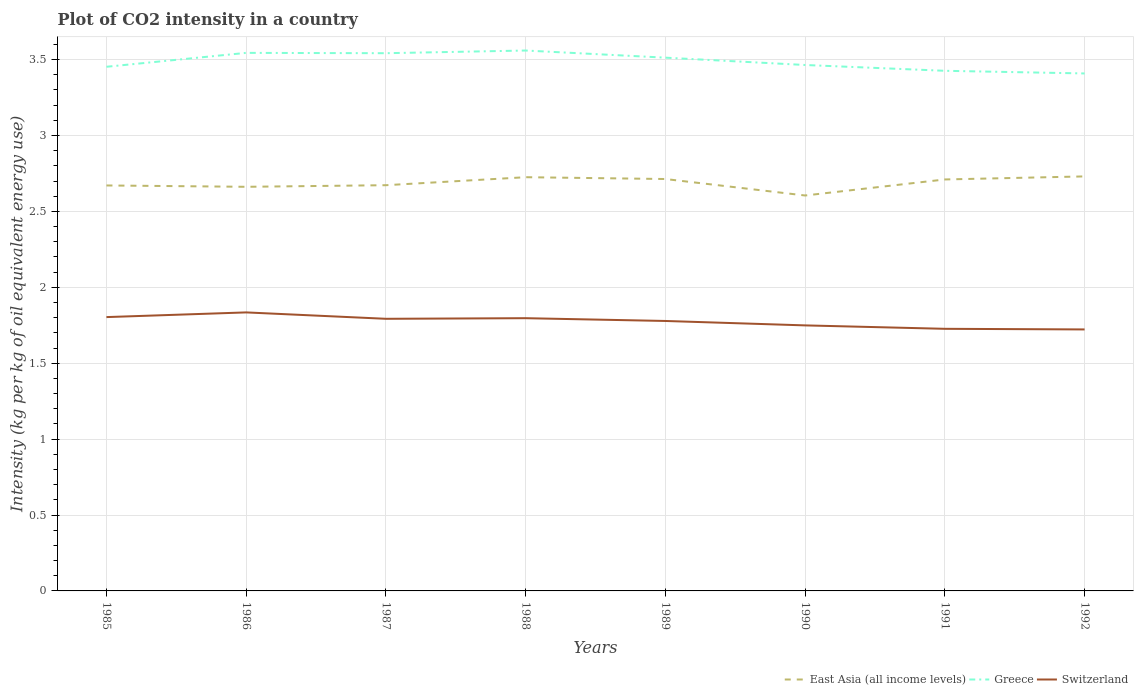Does the line corresponding to Switzerland intersect with the line corresponding to East Asia (all income levels)?
Give a very brief answer. No. Across all years, what is the maximum CO2 intensity in in Greece?
Your response must be concise. 3.41. In which year was the CO2 intensity in in East Asia (all income levels) maximum?
Your answer should be very brief. 1990. What is the total CO2 intensity in in Greece in the graph?
Offer a very short reply. 0.06. What is the difference between the highest and the second highest CO2 intensity in in Switzerland?
Offer a terse response. 0.11. Is the CO2 intensity in in Switzerland strictly greater than the CO2 intensity in in Greece over the years?
Provide a succinct answer. Yes. How many years are there in the graph?
Make the answer very short. 8. Are the values on the major ticks of Y-axis written in scientific E-notation?
Provide a short and direct response. No. Where does the legend appear in the graph?
Your answer should be compact. Bottom right. How are the legend labels stacked?
Your answer should be compact. Horizontal. What is the title of the graph?
Ensure brevity in your answer.  Plot of CO2 intensity in a country. What is the label or title of the Y-axis?
Provide a short and direct response. Intensity (kg per kg of oil equivalent energy use). What is the Intensity (kg per kg of oil equivalent energy use) in East Asia (all income levels) in 1985?
Provide a succinct answer. 2.67. What is the Intensity (kg per kg of oil equivalent energy use) in Greece in 1985?
Keep it short and to the point. 3.45. What is the Intensity (kg per kg of oil equivalent energy use) in Switzerland in 1985?
Provide a short and direct response. 1.8. What is the Intensity (kg per kg of oil equivalent energy use) of East Asia (all income levels) in 1986?
Provide a succinct answer. 2.66. What is the Intensity (kg per kg of oil equivalent energy use) in Greece in 1986?
Your answer should be compact. 3.54. What is the Intensity (kg per kg of oil equivalent energy use) of Switzerland in 1986?
Your response must be concise. 1.83. What is the Intensity (kg per kg of oil equivalent energy use) of East Asia (all income levels) in 1987?
Give a very brief answer. 2.67. What is the Intensity (kg per kg of oil equivalent energy use) in Greece in 1987?
Your answer should be very brief. 3.54. What is the Intensity (kg per kg of oil equivalent energy use) of Switzerland in 1987?
Ensure brevity in your answer.  1.79. What is the Intensity (kg per kg of oil equivalent energy use) of East Asia (all income levels) in 1988?
Your answer should be compact. 2.73. What is the Intensity (kg per kg of oil equivalent energy use) of Greece in 1988?
Your answer should be very brief. 3.56. What is the Intensity (kg per kg of oil equivalent energy use) in Switzerland in 1988?
Your answer should be very brief. 1.8. What is the Intensity (kg per kg of oil equivalent energy use) of East Asia (all income levels) in 1989?
Offer a very short reply. 2.71. What is the Intensity (kg per kg of oil equivalent energy use) of Greece in 1989?
Provide a succinct answer. 3.51. What is the Intensity (kg per kg of oil equivalent energy use) in Switzerland in 1989?
Your answer should be very brief. 1.78. What is the Intensity (kg per kg of oil equivalent energy use) in East Asia (all income levels) in 1990?
Give a very brief answer. 2.6. What is the Intensity (kg per kg of oil equivalent energy use) of Greece in 1990?
Offer a terse response. 3.46. What is the Intensity (kg per kg of oil equivalent energy use) of Switzerland in 1990?
Keep it short and to the point. 1.75. What is the Intensity (kg per kg of oil equivalent energy use) of East Asia (all income levels) in 1991?
Keep it short and to the point. 2.71. What is the Intensity (kg per kg of oil equivalent energy use) of Greece in 1991?
Provide a short and direct response. 3.43. What is the Intensity (kg per kg of oil equivalent energy use) in Switzerland in 1991?
Your answer should be compact. 1.73. What is the Intensity (kg per kg of oil equivalent energy use) in East Asia (all income levels) in 1992?
Your response must be concise. 2.73. What is the Intensity (kg per kg of oil equivalent energy use) in Greece in 1992?
Offer a terse response. 3.41. What is the Intensity (kg per kg of oil equivalent energy use) of Switzerland in 1992?
Your answer should be compact. 1.72. Across all years, what is the maximum Intensity (kg per kg of oil equivalent energy use) in East Asia (all income levels)?
Your answer should be very brief. 2.73. Across all years, what is the maximum Intensity (kg per kg of oil equivalent energy use) of Greece?
Ensure brevity in your answer.  3.56. Across all years, what is the maximum Intensity (kg per kg of oil equivalent energy use) in Switzerland?
Offer a terse response. 1.83. Across all years, what is the minimum Intensity (kg per kg of oil equivalent energy use) of East Asia (all income levels)?
Provide a succinct answer. 2.6. Across all years, what is the minimum Intensity (kg per kg of oil equivalent energy use) in Greece?
Your answer should be very brief. 3.41. Across all years, what is the minimum Intensity (kg per kg of oil equivalent energy use) of Switzerland?
Your answer should be compact. 1.72. What is the total Intensity (kg per kg of oil equivalent energy use) in East Asia (all income levels) in the graph?
Ensure brevity in your answer.  21.49. What is the total Intensity (kg per kg of oil equivalent energy use) in Greece in the graph?
Offer a very short reply. 27.91. What is the total Intensity (kg per kg of oil equivalent energy use) in Switzerland in the graph?
Keep it short and to the point. 14.2. What is the difference between the Intensity (kg per kg of oil equivalent energy use) of East Asia (all income levels) in 1985 and that in 1986?
Your answer should be very brief. 0.01. What is the difference between the Intensity (kg per kg of oil equivalent energy use) of Greece in 1985 and that in 1986?
Your answer should be very brief. -0.09. What is the difference between the Intensity (kg per kg of oil equivalent energy use) of Switzerland in 1985 and that in 1986?
Your answer should be compact. -0.03. What is the difference between the Intensity (kg per kg of oil equivalent energy use) in East Asia (all income levels) in 1985 and that in 1987?
Offer a terse response. -0. What is the difference between the Intensity (kg per kg of oil equivalent energy use) in Greece in 1985 and that in 1987?
Ensure brevity in your answer.  -0.09. What is the difference between the Intensity (kg per kg of oil equivalent energy use) in Switzerland in 1985 and that in 1987?
Keep it short and to the point. 0.01. What is the difference between the Intensity (kg per kg of oil equivalent energy use) in East Asia (all income levels) in 1985 and that in 1988?
Offer a terse response. -0.05. What is the difference between the Intensity (kg per kg of oil equivalent energy use) in Greece in 1985 and that in 1988?
Provide a succinct answer. -0.11. What is the difference between the Intensity (kg per kg of oil equivalent energy use) in Switzerland in 1985 and that in 1988?
Your answer should be compact. 0.01. What is the difference between the Intensity (kg per kg of oil equivalent energy use) of East Asia (all income levels) in 1985 and that in 1989?
Ensure brevity in your answer.  -0.04. What is the difference between the Intensity (kg per kg of oil equivalent energy use) in Greece in 1985 and that in 1989?
Make the answer very short. -0.06. What is the difference between the Intensity (kg per kg of oil equivalent energy use) in Switzerland in 1985 and that in 1989?
Give a very brief answer. 0.03. What is the difference between the Intensity (kg per kg of oil equivalent energy use) of East Asia (all income levels) in 1985 and that in 1990?
Provide a succinct answer. 0.07. What is the difference between the Intensity (kg per kg of oil equivalent energy use) in Greece in 1985 and that in 1990?
Offer a very short reply. -0.01. What is the difference between the Intensity (kg per kg of oil equivalent energy use) in Switzerland in 1985 and that in 1990?
Your answer should be very brief. 0.05. What is the difference between the Intensity (kg per kg of oil equivalent energy use) of East Asia (all income levels) in 1985 and that in 1991?
Ensure brevity in your answer.  -0.04. What is the difference between the Intensity (kg per kg of oil equivalent energy use) of Greece in 1985 and that in 1991?
Ensure brevity in your answer.  0.03. What is the difference between the Intensity (kg per kg of oil equivalent energy use) of Switzerland in 1985 and that in 1991?
Offer a very short reply. 0.08. What is the difference between the Intensity (kg per kg of oil equivalent energy use) in East Asia (all income levels) in 1985 and that in 1992?
Your answer should be compact. -0.06. What is the difference between the Intensity (kg per kg of oil equivalent energy use) in Greece in 1985 and that in 1992?
Your answer should be very brief. 0.04. What is the difference between the Intensity (kg per kg of oil equivalent energy use) of Switzerland in 1985 and that in 1992?
Your answer should be very brief. 0.08. What is the difference between the Intensity (kg per kg of oil equivalent energy use) in East Asia (all income levels) in 1986 and that in 1987?
Give a very brief answer. -0.01. What is the difference between the Intensity (kg per kg of oil equivalent energy use) of Greece in 1986 and that in 1987?
Your answer should be compact. 0. What is the difference between the Intensity (kg per kg of oil equivalent energy use) in Switzerland in 1986 and that in 1987?
Provide a succinct answer. 0.04. What is the difference between the Intensity (kg per kg of oil equivalent energy use) in East Asia (all income levels) in 1986 and that in 1988?
Make the answer very short. -0.06. What is the difference between the Intensity (kg per kg of oil equivalent energy use) in Greece in 1986 and that in 1988?
Make the answer very short. -0.02. What is the difference between the Intensity (kg per kg of oil equivalent energy use) of Switzerland in 1986 and that in 1988?
Offer a very short reply. 0.04. What is the difference between the Intensity (kg per kg of oil equivalent energy use) in East Asia (all income levels) in 1986 and that in 1989?
Your answer should be compact. -0.05. What is the difference between the Intensity (kg per kg of oil equivalent energy use) of Greece in 1986 and that in 1989?
Ensure brevity in your answer.  0.03. What is the difference between the Intensity (kg per kg of oil equivalent energy use) of Switzerland in 1986 and that in 1989?
Your answer should be very brief. 0.06. What is the difference between the Intensity (kg per kg of oil equivalent energy use) of East Asia (all income levels) in 1986 and that in 1990?
Give a very brief answer. 0.06. What is the difference between the Intensity (kg per kg of oil equivalent energy use) in Greece in 1986 and that in 1990?
Provide a succinct answer. 0.08. What is the difference between the Intensity (kg per kg of oil equivalent energy use) of Switzerland in 1986 and that in 1990?
Offer a terse response. 0.09. What is the difference between the Intensity (kg per kg of oil equivalent energy use) of East Asia (all income levels) in 1986 and that in 1991?
Offer a very short reply. -0.05. What is the difference between the Intensity (kg per kg of oil equivalent energy use) of Greece in 1986 and that in 1991?
Your response must be concise. 0.12. What is the difference between the Intensity (kg per kg of oil equivalent energy use) in Switzerland in 1986 and that in 1991?
Offer a terse response. 0.11. What is the difference between the Intensity (kg per kg of oil equivalent energy use) in East Asia (all income levels) in 1986 and that in 1992?
Make the answer very short. -0.07. What is the difference between the Intensity (kg per kg of oil equivalent energy use) of Greece in 1986 and that in 1992?
Your answer should be very brief. 0.14. What is the difference between the Intensity (kg per kg of oil equivalent energy use) of Switzerland in 1986 and that in 1992?
Your response must be concise. 0.11. What is the difference between the Intensity (kg per kg of oil equivalent energy use) of East Asia (all income levels) in 1987 and that in 1988?
Offer a very short reply. -0.05. What is the difference between the Intensity (kg per kg of oil equivalent energy use) in Greece in 1987 and that in 1988?
Keep it short and to the point. -0.02. What is the difference between the Intensity (kg per kg of oil equivalent energy use) of Switzerland in 1987 and that in 1988?
Provide a succinct answer. -0. What is the difference between the Intensity (kg per kg of oil equivalent energy use) in East Asia (all income levels) in 1987 and that in 1989?
Offer a terse response. -0.04. What is the difference between the Intensity (kg per kg of oil equivalent energy use) of Greece in 1987 and that in 1989?
Your answer should be compact. 0.03. What is the difference between the Intensity (kg per kg of oil equivalent energy use) of Switzerland in 1987 and that in 1989?
Your answer should be very brief. 0.01. What is the difference between the Intensity (kg per kg of oil equivalent energy use) of East Asia (all income levels) in 1987 and that in 1990?
Offer a very short reply. 0.07. What is the difference between the Intensity (kg per kg of oil equivalent energy use) in Greece in 1987 and that in 1990?
Give a very brief answer. 0.08. What is the difference between the Intensity (kg per kg of oil equivalent energy use) in Switzerland in 1987 and that in 1990?
Keep it short and to the point. 0.04. What is the difference between the Intensity (kg per kg of oil equivalent energy use) of East Asia (all income levels) in 1987 and that in 1991?
Offer a very short reply. -0.04. What is the difference between the Intensity (kg per kg of oil equivalent energy use) in Greece in 1987 and that in 1991?
Your answer should be compact. 0.12. What is the difference between the Intensity (kg per kg of oil equivalent energy use) in Switzerland in 1987 and that in 1991?
Offer a very short reply. 0.07. What is the difference between the Intensity (kg per kg of oil equivalent energy use) of East Asia (all income levels) in 1987 and that in 1992?
Your answer should be compact. -0.06. What is the difference between the Intensity (kg per kg of oil equivalent energy use) in Greece in 1987 and that in 1992?
Your answer should be compact. 0.13. What is the difference between the Intensity (kg per kg of oil equivalent energy use) of Switzerland in 1987 and that in 1992?
Keep it short and to the point. 0.07. What is the difference between the Intensity (kg per kg of oil equivalent energy use) of East Asia (all income levels) in 1988 and that in 1989?
Your response must be concise. 0.01. What is the difference between the Intensity (kg per kg of oil equivalent energy use) of Greece in 1988 and that in 1989?
Your response must be concise. 0.05. What is the difference between the Intensity (kg per kg of oil equivalent energy use) of Switzerland in 1988 and that in 1989?
Offer a terse response. 0.02. What is the difference between the Intensity (kg per kg of oil equivalent energy use) in East Asia (all income levels) in 1988 and that in 1990?
Give a very brief answer. 0.12. What is the difference between the Intensity (kg per kg of oil equivalent energy use) in Greece in 1988 and that in 1990?
Ensure brevity in your answer.  0.1. What is the difference between the Intensity (kg per kg of oil equivalent energy use) of Switzerland in 1988 and that in 1990?
Keep it short and to the point. 0.05. What is the difference between the Intensity (kg per kg of oil equivalent energy use) in East Asia (all income levels) in 1988 and that in 1991?
Make the answer very short. 0.01. What is the difference between the Intensity (kg per kg of oil equivalent energy use) in Greece in 1988 and that in 1991?
Give a very brief answer. 0.13. What is the difference between the Intensity (kg per kg of oil equivalent energy use) in Switzerland in 1988 and that in 1991?
Your response must be concise. 0.07. What is the difference between the Intensity (kg per kg of oil equivalent energy use) in East Asia (all income levels) in 1988 and that in 1992?
Your response must be concise. -0.01. What is the difference between the Intensity (kg per kg of oil equivalent energy use) of Greece in 1988 and that in 1992?
Your response must be concise. 0.15. What is the difference between the Intensity (kg per kg of oil equivalent energy use) of Switzerland in 1988 and that in 1992?
Provide a succinct answer. 0.07. What is the difference between the Intensity (kg per kg of oil equivalent energy use) of East Asia (all income levels) in 1989 and that in 1990?
Give a very brief answer. 0.11. What is the difference between the Intensity (kg per kg of oil equivalent energy use) of Greece in 1989 and that in 1990?
Offer a very short reply. 0.05. What is the difference between the Intensity (kg per kg of oil equivalent energy use) in Switzerland in 1989 and that in 1990?
Your answer should be compact. 0.03. What is the difference between the Intensity (kg per kg of oil equivalent energy use) in East Asia (all income levels) in 1989 and that in 1991?
Give a very brief answer. 0. What is the difference between the Intensity (kg per kg of oil equivalent energy use) in Greece in 1989 and that in 1991?
Your answer should be very brief. 0.09. What is the difference between the Intensity (kg per kg of oil equivalent energy use) of Switzerland in 1989 and that in 1991?
Your answer should be very brief. 0.05. What is the difference between the Intensity (kg per kg of oil equivalent energy use) in East Asia (all income levels) in 1989 and that in 1992?
Provide a succinct answer. -0.02. What is the difference between the Intensity (kg per kg of oil equivalent energy use) of Greece in 1989 and that in 1992?
Your response must be concise. 0.1. What is the difference between the Intensity (kg per kg of oil equivalent energy use) in Switzerland in 1989 and that in 1992?
Your response must be concise. 0.06. What is the difference between the Intensity (kg per kg of oil equivalent energy use) in East Asia (all income levels) in 1990 and that in 1991?
Make the answer very short. -0.11. What is the difference between the Intensity (kg per kg of oil equivalent energy use) in Greece in 1990 and that in 1991?
Your response must be concise. 0.04. What is the difference between the Intensity (kg per kg of oil equivalent energy use) in Switzerland in 1990 and that in 1991?
Give a very brief answer. 0.02. What is the difference between the Intensity (kg per kg of oil equivalent energy use) of East Asia (all income levels) in 1990 and that in 1992?
Offer a terse response. -0.13. What is the difference between the Intensity (kg per kg of oil equivalent energy use) in Greece in 1990 and that in 1992?
Your answer should be compact. 0.06. What is the difference between the Intensity (kg per kg of oil equivalent energy use) in Switzerland in 1990 and that in 1992?
Keep it short and to the point. 0.03. What is the difference between the Intensity (kg per kg of oil equivalent energy use) in East Asia (all income levels) in 1991 and that in 1992?
Your answer should be very brief. -0.02. What is the difference between the Intensity (kg per kg of oil equivalent energy use) in Greece in 1991 and that in 1992?
Provide a short and direct response. 0.02. What is the difference between the Intensity (kg per kg of oil equivalent energy use) in Switzerland in 1991 and that in 1992?
Give a very brief answer. 0. What is the difference between the Intensity (kg per kg of oil equivalent energy use) of East Asia (all income levels) in 1985 and the Intensity (kg per kg of oil equivalent energy use) of Greece in 1986?
Your answer should be very brief. -0.87. What is the difference between the Intensity (kg per kg of oil equivalent energy use) in East Asia (all income levels) in 1985 and the Intensity (kg per kg of oil equivalent energy use) in Switzerland in 1986?
Provide a succinct answer. 0.84. What is the difference between the Intensity (kg per kg of oil equivalent energy use) of Greece in 1985 and the Intensity (kg per kg of oil equivalent energy use) of Switzerland in 1986?
Provide a succinct answer. 1.62. What is the difference between the Intensity (kg per kg of oil equivalent energy use) in East Asia (all income levels) in 1985 and the Intensity (kg per kg of oil equivalent energy use) in Greece in 1987?
Provide a succinct answer. -0.87. What is the difference between the Intensity (kg per kg of oil equivalent energy use) of East Asia (all income levels) in 1985 and the Intensity (kg per kg of oil equivalent energy use) of Switzerland in 1987?
Offer a terse response. 0.88. What is the difference between the Intensity (kg per kg of oil equivalent energy use) in Greece in 1985 and the Intensity (kg per kg of oil equivalent energy use) in Switzerland in 1987?
Your response must be concise. 1.66. What is the difference between the Intensity (kg per kg of oil equivalent energy use) of East Asia (all income levels) in 1985 and the Intensity (kg per kg of oil equivalent energy use) of Greece in 1988?
Your answer should be compact. -0.89. What is the difference between the Intensity (kg per kg of oil equivalent energy use) in East Asia (all income levels) in 1985 and the Intensity (kg per kg of oil equivalent energy use) in Switzerland in 1988?
Provide a succinct answer. 0.87. What is the difference between the Intensity (kg per kg of oil equivalent energy use) of Greece in 1985 and the Intensity (kg per kg of oil equivalent energy use) of Switzerland in 1988?
Provide a succinct answer. 1.66. What is the difference between the Intensity (kg per kg of oil equivalent energy use) in East Asia (all income levels) in 1985 and the Intensity (kg per kg of oil equivalent energy use) in Greece in 1989?
Your answer should be compact. -0.84. What is the difference between the Intensity (kg per kg of oil equivalent energy use) of East Asia (all income levels) in 1985 and the Intensity (kg per kg of oil equivalent energy use) of Switzerland in 1989?
Give a very brief answer. 0.89. What is the difference between the Intensity (kg per kg of oil equivalent energy use) of Greece in 1985 and the Intensity (kg per kg of oil equivalent energy use) of Switzerland in 1989?
Ensure brevity in your answer.  1.67. What is the difference between the Intensity (kg per kg of oil equivalent energy use) in East Asia (all income levels) in 1985 and the Intensity (kg per kg of oil equivalent energy use) in Greece in 1990?
Ensure brevity in your answer.  -0.79. What is the difference between the Intensity (kg per kg of oil equivalent energy use) in East Asia (all income levels) in 1985 and the Intensity (kg per kg of oil equivalent energy use) in Switzerland in 1990?
Offer a terse response. 0.92. What is the difference between the Intensity (kg per kg of oil equivalent energy use) of Greece in 1985 and the Intensity (kg per kg of oil equivalent energy use) of Switzerland in 1990?
Keep it short and to the point. 1.7. What is the difference between the Intensity (kg per kg of oil equivalent energy use) of East Asia (all income levels) in 1985 and the Intensity (kg per kg of oil equivalent energy use) of Greece in 1991?
Ensure brevity in your answer.  -0.76. What is the difference between the Intensity (kg per kg of oil equivalent energy use) in East Asia (all income levels) in 1985 and the Intensity (kg per kg of oil equivalent energy use) in Switzerland in 1991?
Ensure brevity in your answer.  0.94. What is the difference between the Intensity (kg per kg of oil equivalent energy use) in Greece in 1985 and the Intensity (kg per kg of oil equivalent energy use) in Switzerland in 1991?
Provide a succinct answer. 1.73. What is the difference between the Intensity (kg per kg of oil equivalent energy use) of East Asia (all income levels) in 1985 and the Intensity (kg per kg of oil equivalent energy use) of Greece in 1992?
Your answer should be compact. -0.74. What is the difference between the Intensity (kg per kg of oil equivalent energy use) in East Asia (all income levels) in 1985 and the Intensity (kg per kg of oil equivalent energy use) in Switzerland in 1992?
Your answer should be very brief. 0.95. What is the difference between the Intensity (kg per kg of oil equivalent energy use) in Greece in 1985 and the Intensity (kg per kg of oil equivalent energy use) in Switzerland in 1992?
Offer a terse response. 1.73. What is the difference between the Intensity (kg per kg of oil equivalent energy use) in East Asia (all income levels) in 1986 and the Intensity (kg per kg of oil equivalent energy use) in Greece in 1987?
Ensure brevity in your answer.  -0.88. What is the difference between the Intensity (kg per kg of oil equivalent energy use) in East Asia (all income levels) in 1986 and the Intensity (kg per kg of oil equivalent energy use) in Switzerland in 1987?
Your answer should be compact. 0.87. What is the difference between the Intensity (kg per kg of oil equivalent energy use) of Greece in 1986 and the Intensity (kg per kg of oil equivalent energy use) of Switzerland in 1987?
Your response must be concise. 1.75. What is the difference between the Intensity (kg per kg of oil equivalent energy use) of East Asia (all income levels) in 1986 and the Intensity (kg per kg of oil equivalent energy use) of Greece in 1988?
Provide a succinct answer. -0.9. What is the difference between the Intensity (kg per kg of oil equivalent energy use) of East Asia (all income levels) in 1986 and the Intensity (kg per kg of oil equivalent energy use) of Switzerland in 1988?
Offer a terse response. 0.87. What is the difference between the Intensity (kg per kg of oil equivalent energy use) in Greece in 1986 and the Intensity (kg per kg of oil equivalent energy use) in Switzerland in 1988?
Your answer should be compact. 1.75. What is the difference between the Intensity (kg per kg of oil equivalent energy use) of East Asia (all income levels) in 1986 and the Intensity (kg per kg of oil equivalent energy use) of Greece in 1989?
Your answer should be compact. -0.85. What is the difference between the Intensity (kg per kg of oil equivalent energy use) in East Asia (all income levels) in 1986 and the Intensity (kg per kg of oil equivalent energy use) in Switzerland in 1989?
Provide a succinct answer. 0.88. What is the difference between the Intensity (kg per kg of oil equivalent energy use) in Greece in 1986 and the Intensity (kg per kg of oil equivalent energy use) in Switzerland in 1989?
Your answer should be very brief. 1.77. What is the difference between the Intensity (kg per kg of oil equivalent energy use) of East Asia (all income levels) in 1986 and the Intensity (kg per kg of oil equivalent energy use) of Greece in 1990?
Offer a very short reply. -0.8. What is the difference between the Intensity (kg per kg of oil equivalent energy use) of East Asia (all income levels) in 1986 and the Intensity (kg per kg of oil equivalent energy use) of Switzerland in 1990?
Your response must be concise. 0.91. What is the difference between the Intensity (kg per kg of oil equivalent energy use) in Greece in 1986 and the Intensity (kg per kg of oil equivalent energy use) in Switzerland in 1990?
Your answer should be compact. 1.8. What is the difference between the Intensity (kg per kg of oil equivalent energy use) of East Asia (all income levels) in 1986 and the Intensity (kg per kg of oil equivalent energy use) of Greece in 1991?
Offer a terse response. -0.76. What is the difference between the Intensity (kg per kg of oil equivalent energy use) in East Asia (all income levels) in 1986 and the Intensity (kg per kg of oil equivalent energy use) in Switzerland in 1991?
Offer a very short reply. 0.94. What is the difference between the Intensity (kg per kg of oil equivalent energy use) in Greece in 1986 and the Intensity (kg per kg of oil equivalent energy use) in Switzerland in 1991?
Provide a short and direct response. 1.82. What is the difference between the Intensity (kg per kg of oil equivalent energy use) of East Asia (all income levels) in 1986 and the Intensity (kg per kg of oil equivalent energy use) of Greece in 1992?
Make the answer very short. -0.75. What is the difference between the Intensity (kg per kg of oil equivalent energy use) in East Asia (all income levels) in 1986 and the Intensity (kg per kg of oil equivalent energy use) in Switzerland in 1992?
Offer a terse response. 0.94. What is the difference between the Intensity (kg per kg of oil equivalent energy use) in Greece in 1986 and the Intensity (kg per kg of oil equivalent energy use) in Switzerland in 1992?
Make the answer very short. 1.82. What is the difference between the Intensity (kg per kg of oil equivalent energy use) of East Asia (all income levels) in 1987 and the Intensity (kg per kg of oil equivalent energy use) of Greece in 1988?
Your answer should be compact. -0.89. What is the difference between the Intensity (kg per kg of oil equivalent energy use) of East Asia (all income levels) in 1987 and the Intensity (kg per kg of oil equivalent energy use) of Switzerland in 1988?
Provide a short and direct response. 0.88. What is the difference between the Intensity (kg per kg of oil equivalent energy use) of Greece in 1987 and the Intensity (kg per kg of oil equivalent energy use) of Switzerland in 1988?
Your answer should be very brief. 1.75. What is the difference between the Intensity (kg per kg of oil equivalent energy use) in East Asia (all income levels) in 1987 and the Intensity (kg per kg of oil equivalent energy use) in Greece in 1989?
Your answer should be very brief. -0.84. What is the difference between the Intensity (kg per kg of oil equivalent energy use) in East Asia (all income levels) in 1987 and the Intensity (kg per kg of oil equivalent energy use) in Switzerland in 1989?
Ensure brevity in your answer.  0.89. What is the difference between the Intensity (kg per kg of oil equivalent energy use) of Greece in 1987 and the Intensity (kg per kg of oil equivalent energy use) of Switzerland in 1989?
Give a very brief answer. 1.76. What is the difference between the Intensity (kg per kg of oil equivalent energy use) of East Asia (all income levels) in 1987 and the Intensity (kg per kg of oil equivalent energy use) of Greece in 1990?
Offer a very short reply. -0.79. What is the difference between the Intensity (kg per kg of oil equivalent energy use) in East Asia (all income levels) in 1987 and the Intensity (kg per kg of oil equivalent energy use) in Switzerland in 1990?
Provide a succinct answer. 0.92. What is the difference between the Intensity (kg per kg of oil equivalent energy use) of Greece in 1987 and the Intensity (kg per kg of oil equivalent energy use) of Switzerland in 1990?
Ensure brevity in your answer.  1.79. What is the difference between the Intensity (kg per kg of oil equivalent energy use) of East Asia (all income levels) in 1987 and the Intensity (kg per kg of oil equivalent energy use) of Greece in 1991?
Your answer should be very brief. -0.75. What is the difference between the Intensity (kg per kg of oil equivalent energy use) in East Asia (all income levels) in 1987 and the Intensity (kg per kg of oil equivalent energy use) in Switzerland in 1991?
Keep it short and to the point. 0.95. What is the difference between the Intensity (kg per kg of oil equivalent energy use) of Greece in 1987 and the Intensity (kg per kg of oil equivalent energy use) of Switzerland in 1991?
Your answer should be compact. 1.82. What is the difference between the Intensity (kg per kg of oil equivalent energy use) of East Asia (all income levels) in 1987 and the Intensity (kg per kg of oil equivalent energy use) of Greece in 1992?
Your response must be concise. -0.74. What is the difference between the Intensity (kg per kg of oil equivalent energy use) in East Asia (all income levels) in 1987 and the Intensity (kg per kg of oil equivalent energy use) in Switzerland in 1992?
Your answer should be compact. 0.95. What is the difference between the Intensity (kg per kg of oil equivalent energy use) of Greece in 1987 and the Intensity (kg per kg of oil equivalent energy use) of Switzerland in 1992?
Your response must be concise. 1.82. What is the difference between the Intensity (kg per kg of oil equivalent energy use) of East Asia (all income levels) in 1988 and the Intensity (kg per kg of oil equivalent energy use) of Greece in 1989?
Give a very brief answer. -0.79. What is the difference between the Intensity (kg per kg of oil equivalent energy use) of East Asia (all income levels) in 1988 and the Intensity (kg per kg of oil equivalent energy use) of Switzerland in 1989?
Your response must be concise. 0.95. What is the difference between the Intensity (kg per kg of oil equivalent energy use) of Greece in 1988 and the Intensity (kg per kg of oil equivalent energy use) of Switzerland in 1989?
Give a very brief answer. 1.78. What is the difference between the Intensity (kg per kg of oil equivalent energy use) of East Asia (all income levels) in 1988 and the Intensity (kg per kg of oil equivalent energy use) of Greece in 1990?
Keep it short and to the point. -0.74. What is the difference between the Intensity (kg per kg of oil equivalent energy use) of East Asia (all income levels) in 1988 and the Intensity (kg per kg of oil equivalent energy use) of Switzerland in 1990?
Provide a succinct answer. 0.98. What is the difference between the Intensity (kg per kg of oil equivalent energy use) of Greece in 1988 and the Intensity (kg per kg of oil equivalent energy use) of Switzerland in 1990?
Ensure brevity in your answer.  1.81. What is the difference between the Intensity (kg per kg of oil equivalent energy use) of East Asia (all income levels) in 1988 and the Intensity (kg per kg of oil equivalent energy use) of Greece in 1991?
Your answer should be compact. -0.7. What is the difference between the Intensity (kg per kg of oil equivalent energy use) in East Asia (all income levels) in 1988 and the Intensity (kg per kg of oil equivalent energy use) in Switzerland in 1991?
Your answer should be compact. 1. What is the difference between the Intensity (kg per kg of oil equivalent energy use) of Greece in 1988 and the Intensity (kg per kg of oil equivalent energy use) of Switzerland in 1991?
Provide a succinct answer. 1.83. What is the difference between the Intensity (kg per kg of oil equivalent energy use) in East Asia (all income levels) in 1988 and the Intensity (kg per kg of oil equivalent energy use) in Greece in 1992?
Provide a short and direct response. -0.68. What is the difference between the Intensity (kg per kg of oil equivalent energy use) of Greece in 1988 and the Intensity (kg per kg of oil equivalent energy use) of Switzerland in 1992?
Offer a terse response. 1.84. What is the difference between the Intensity (kg per kg of oil equivalent energy use) in East Asia (all income levels) in 1989 and the Intensity (kg per kg of oil equivalent energy use) in Greece in 1990?
Your answer should be very brief. -0.75. What is the difference between the Intensity (kg per kg of oil equivalent energy use) of East Asia (all income levels) in 1989 and the Intensity (kg per kg of oil equivalent energy use) of Switzerland in 1990?
Your response must be concise. 0.96. What is the difference between the Intensity (kg per kg of oil equivalent energy use) of Greece in 1989 and the Intensity (kg per kg of oil equivalent energy use) of Switzerland in 1990?
Keep it short and to the point. 1.76. What is the difference between the Intensity (kg per kg of oil equivalent energy use) in East Asia (all income levels) in 1989 and the Intensity (kg per kg of oil equivalent energy use) in Greece in 1991?
Offer a very short reply. -0.71. What is the difference between the Intensity (kg per kg of oil equivalent energy use) of East Asia (all income levels) in 1989 and the Intensity (kg per kg of oil equivalent energy use) of Switzerland in 1991?
Ensure brevity in your answer.  0.99. What is the difference between the Intensity (kg per kg of oil equivalent energy use) in Greece in 1989 and the Intensity (kg per kg of oil equivalent energy use) in Switzerland in 1991?
Provide a succinct answer. 1.79. What is the difference between the Intensity (kg per kg of oil equivalent energy use) in East Asia (all income levels) in 1989 and the Intensity (kg per kg of oil equivalent energy use) in Greece in 1992?
Your response must be concise. -0.7. What is the difference between the Intensity (kg per kg of oil equivalent energy use) of East Asia (all income levels) in 1989 and the Intensity (kg per kg of oil equivalent energy use) of Switzerland in 1992?
Your answer should be compact. 0.99. What is the difference between the Intensity (kg per kg of oil equivalent energy use) of Greece in 1989 and the Intensity (kg per kg of oil equivalent energy use) of Switzerland in 1992?
Keep it short and to the point. 1.79. What is the difference between the Intensity (kg per kg of oil equivalent energy use) in East Asia (all income levels) in 1990 and the Intensity (kg per kg of oil equivalent energy use) in Greece in 1991?
Provide a short and direct response. -0.82. What is the difference between the Intensity (kg per kg of oil equivalent energy use) of East Asia (all income levels) in 1990 and the Intensity (kg per kg of oil equivalent energy use) of Switzerland in 1991?
Give a very brief answer. 0.88. What is the difference between the Intensity (kg per kg of oil equivalent energy use) of Greece in 1990 and the Intensity (kg per kg of oil equivalent energy use) of Switzerland in 1991?
Provide a short and direct response. 1.74. What is the difference between the Intensity (kg per kg of oil equivalent energy use) in East Asia (all income levels) in 1990 and the Intensity (kg per kg of oil equivalent energy use) in Greece in 1992?
Your answer should be very brief. -0.8. What is the difference between the Intensity (kg per kg of oil equivalent energy use) in East Asia (all income levels) in 1990 and the Intensity (kg per kg of oil equivalent energy use) in Switzerland in 1992?
Ensure brevity in your answer.  0.88. What is the difference between the Intensity (kg per kg of oil equivalent energy use) in Greece in 1990 and the Intensity (kg per kg of oil equivalent energy use) in Switzerland in 1992?
Your answer should be compact. 1.74. What is the difference between the Intensity (kg per kg of oil equivalent energy use) of East Asia (all income levels) in 1991 and the Intensity (kg per kg of oil equivalent energy use) of Greece in 1992?
Provide a short and direct response. -0.7. What is the difference between the Intensity (kg per kg of oil equivalent energy use) of East Asia (all income levels) in 1991 and the Intensity (kg per kg of oil equivalent energy use) of Switzerland in 1992?
Ensure brevity in your answer.  0.99. What is the difference between the Intensity (kg per kg of oil equivalent energy use) in Greece in 1991 and the Intensity (kg per kg of oil equivalent energy use) in Switzerland in 1992?
Your response must be concise. 1.7. What is the average Intensity (kg per kg of oil equivalent energy use) of East Asia (all income levels) per year?
Your answer should be compact. 2.69. What is the average Intensity (kg per kg of oil equivalent energy use) of Greece per year?
Your response must be concise. 3.49. What is the average Intensity (kg per kg of oil equivalent energy use) in Switzerland per year?
Your response must be concise. 1.78. In the year 1985, what is the difference between the Intensity (kg per kg of oil equivalent energy use) of East Asia (all income levels) and Intensity (kg per kg of oil equivalent energy use) of Greece?
Your answer should be compact. -0.78. In the year 1985, what is the difference between the Intensity (kg per kg of oil equivalent energy use) in East Asia (all income levels) and Intensity (kg per kg of oil equivalent energy use) in Switzerland?
Give a very brief answer. 0.87. In the year 1985, what is the difference between the Intensity (kg per kg of oil equivalent energy use) in Greece and Intensity (kg per kg of oil equivalent energy use) in Switzerland?
Give a very brief answer. 1.65. In the year 1986, what is the difference between the Intensity (kg per kg of oil equivalent energy use) of East Asia (all income levels) and Intensity (kg per kg of oil equivalent energy use) of Greece?
Keep it short and to the point. -0.88. In the year 1986, what is the difference between the Intensity (kg per kg of oil equivalent energy use) of East Asia (all income levels) and Intensity (kg per kg of oil equivalent energy use) of Switzerland?
Your answer should be very brief. 0.83. In the year 1986, what is the difference between the Intensity (kg per kg of oil equivalent energy use) of Greece and Intensity (kg per kg of oil equivalent energy use) of Switzerland?
Your answer should be very brief. 1.71. In the year 1987, what is the difference between the Intensity (kg per kg of oil equivalent energy use) of East Asia (all income levels) and Intensity (kg per kg of oil equivalent energy use) of Greece?
Make the answer very short. -0.87. In the year 1987, what is the difference between the Intensity (kg per kg of oil equivalent energy use) of Greece and Intensity (kg per kg of oil equivalent energy use) of Switzerland?
Make the answer very short. 1.75. In the year 1988, what is the difference between the Intensity (kg per kg of oil equivalent energy use) in East Asia (all income levels) and Intensity (kg per kg of oil equivalent energy use) in Greece?
Make the answer very short. -0.83. In the year 1988, what is the difference between the Intensity (kg per kg of oil equivalent energy use) of East Asia (all income levels) and Intensity (kg per kg of oil equivalent energy use) of Switzerland?
Offer a very short reply. 0.93. In the year 1988, what is the difference between the Intensity (kg per kg of oil equivalent energy use) of Greece and Intensity (kg per kg of oil equivalent energy use) of Switzerland?
Your answer should be very brief. 1.76. In the year 1989, what is the difference between the Intensity (kg per kg of oil equivalent energy use) in East Asia (all income levels) and Intensity (kg per kg of oil equivalent energy use) in Greece?
Provide a succinct answer. -0.8. In the year 1989, what is the difference between the Intensity (kg per kg of oil equivalent energy use) of East Asia (all income levels) and Intensity (kg per kg of oil equivalent energy use) of Switzerland?
Ensure brevity in your answer.  0.94. In the year 1989, what is the difference between the Intensity (kg per kg of oil equivalent energy use) of Greece and Intensity (kg per kg of oil equivalent energy use) of Switzerland?
Make the answer very short. 1.73. In the year 1990, what is the difference between the Intensity (kg per kg of oil equivalent energy use) of East Asia (all income levels) and Intensity (kg per kg of oil equivalent energy use) of Greece?
Give a very brief answer. -0.86. In the year 1990, what is the difference between the Intensity (kg per kg of oil equivalent energy use) in East Asia (all income levels) and Intensity (kg per kg of oil equivalent energy use) in Switzerland?
Your answer should be compact. 0.86. In the year 1990, what is the difference between the Intensity (kg per kg of oil equivalent energy use) of Greece and Intensity (kg per kg of oil equivalent energy use) of Switzerland?
Offer a very short reply. 1.72. In the year 1991, what is the difference between the Intensity (kg per kg of oil equivalent energy use) in East Asia (all income levels) and Intensity (kg per kg of oil equivalent energy use) in Greece?
Ensure brevity in your answer.  -0.72. In the year 1991, what is the difference between the Intensity (kg per kg of oil equivalent energy use) of East Asia (all income levels) and Intensity (kg per kg of oil equivalent energy use) of Switzerland?
Provide a succinct answer. 0.98. In the year 1991, what is the difference between the Intensity (kg per kg of oil equivalent energy use) of Greece and Intensity (kg per kg of oil equivalent energy use) of Switzerland?
Your response must be concise. 1.7. In the year 1992, what is the difference between the Intensity (kg per kg of oil equivalent energy use) of East Asia (all income levels) and Intensity (kg per kg of oil equivalent energy use) of Greece?
Provide a short and direct response. -0.68. In the year 1992, what is the difference between the Intensity (kg per kg of oil equivalent energy use) of East Asia (all income levels) and Intensity (kg per kg of oil equivalent energy use) of Switzerland?
Your answer should be very brief. 1.01. In the year 1992, what is the difference between the Intensity (kg per kg of oil equivalent energy use) in Greece and Intensity (kg per kg of oil equivalent energy use) in Switzerland?
Keep it short and to the point. 1.69. What is the ratio of the Intensity (kg per kg of oil equivalent energy use) of Greece in 1985 to that in 1986?
Provide a short and direct response. 0.97. What is the ratio of the Intensity (kg per kg of oil equivalent energy use) of Switzerland in 1985 to that in 1986?
Offer a very short reply. 0.98. What is the ratio of the Intensity (kg per kg of oil equivalent energy use) in East Asia (all income levels) in 1985 to that in 1987?
Keep it short and to the point. 1. What is the ratio of the Intensity (kg per kg of oil equivalent energy use) of Greece in 1985 to that in 1987?
Provide a short and direct response. 0.97. What is the ratio of the Intensity (kg per kg of oil equivalent energy use) in Switzerland in 1985 to that in 1987?
Provide a short and direct response. 1.01. What is the ratio of the Intensity (kg per kg of oil equivalent energy use) in East Asia (all income levels) in 1985 to that in 1988?
Provide a short and direct response. 0.98. What is the ratio of the Intensity (kg per kg of oil equivalent energy use) in Greece in 1985 to that in 1988?
Your answer should be very brief. 0.97. What is the ratio of the Intensity (kg per kg of oil equivalent energy use) in East Asia (all income levels) in 1985 to that in 1989?
Your answer should be compact. 0.98. What is the ratio of the Intensity (kg per kg of oil equivalent energy use) of Greece in 1985 to that in 1989?
Give a very brief answer. 0.98. What is the ratio of the Intensity (kg per kg of oil equivalent energy use) in Switzerland in 1985 to that in 1989?
Your answer should be very brief. 1.01. What is the ratio of the Intensity (kg per kg of oil equivalent energy use) of East Asia (all income levels) in 1985 to that in 1990?
Offer a very short reply. 1.03. What is the ratio of the Intensity (kg per kg of oil equivalent energy use) of Greece in 1985 to that in 1990?
Offer a terse response. 1. What is the ratio of the Intensity (kg per kg of oil equivalent energy use) of Switzerland in 1985 to that in 1990?
Your answer should be compact. 1.03. What is the ratio of the Intensity (kg per kg of oil equivalent energy use) in East Asia (all income levels) in 1985 to that in 1991?
Your answer should be very brief. 0.99. What is the ratio of the Intensity (kg per kg of oil equivalent energy use) of Greece in 1985 to that in 1991?
Offer a very short reply. 1.01. What is the ratio of the Intensity (kg per kg of oil equivalent energy use) of Switzerland in 1985 to that in 1991?
Give a very brief answer. 1.04. What is the ratio of the Intensity (kg per kg of oil equivalent energy use) in East Asia (all income levels) in 1985 to that in 1992?
Keep it short and to the point. 0.98. What is the ratio of the Intensity (kg per kg of oil equivalent energy use) of Greece in 1985 to that in 1992?
Provide a short and direct response. 1.01. What is the ratio of the Intensity (kg per kg of oil equivalent energy use) in Switzerland in 1985 to that in 1992?
Your answer should be very brief. 1.05. What is the ratio of the Intensity (kg per kg of oil equivalent energy use) of East Asia (all income levels) in 1986 to that in 1987?
Keep it short and to the point. 1. What is the ratio of the Intensity (kg per kg of oil equivalent energy use) in Greece in 1986 to that in 1987?
Your answer should be compact. 1. What is the ratio of the Intensity (kg per kg of oil equivalent energy use) in Switzerland in 1986 to that in 1987?
Offer a terse response. 1.02. What is the ratio of the Intensity (kg per kg of oil equivalent energy use) of East Asia (all income levels) in 1986 to that in 1988?
Offer a very short reply. 0.98. What is the ratio of the Intensity (kg per kg of oil equivalent energy use) of Switzerland in 1986 to that in 1988?
Make the answer very short. 1.02. What is the ratio of the Intensity (kg per kg of oil equivalent energy use) in East Asia (all income levels) in 1986 to that in 1989?
Provide a succinct answer. 0.98. What is the ratio of the Intensity (kg per kg of oil equivalent energy use) in Greece in 1986 to that in 1989?
Your answer should be compact. 1.01. What is the ratio of the Intensity (kg per kg of oil equivalent energy use) of Switzerland in 1986 to that in 1989?
Make the answer very short. 1.03. What is the ratio of the Intensity (kg per kg of oil equivalent energy use) of East Asia (all income levels) in 1986 to that in 1990?
Keep it short and to the point. 1.02. What is the ratio of the Intensity (kg per kg of oil equivalent energy use) of Greece in 1986 to that in 1990?
Your answer should be very brief. 1.02. What is the ratio of the Intensity (kg per kg of oil equivalent energy use) in Switzerland in 1986 to that in 1990?
Ensure brevity in your answer.  1.05. What is the ratio of the Intensity (kg per kg of oil equivalent energy use) in East Asia (all income levels) in 1986 to that in 1991?
Your answer should be compact. 0.98. What is the ratio of the Intensity (kg per kg of oil equivalent energy use) of Greece in 1986 to that in 1991?
Your response must be concise. 1.03. What is the ratio of the Intensity (kg per kg of oil equivalent energy use) in East Asia (all income levels) in 1986 to that in 1992?
Make the answer very short. 0.97. What is the ratio of the Intensity (kg per kg of oil equivalent energy use) in Greece in 1986 to that in 1992?
Your answer should be very brief. 1.04. What is the ratio of the Intensity (kg per kg of oil equivalent energy use) of Switzerland in 1986 to that in 1992?
Make the answer very short. 1.07. What is the ratio of the Intensity (kg per kg of oil equivalent energy use) of East Asia (all income levels) in 1987 to that in 1988?
Provide a succinct answer. 0.98. What is the ratio of the Intensity (kg per kg of oil equivalent energy use) of Greece in 1987 to that in 1988?
Provide a succinct answer. 0.99. What is the ratio of the Intensity (kg per kg of oil equivalent energy use) of Switzerland in 1987 to that in 1988?
Offer a very short reply. 1. What is the ratio of the Intensity (kg per kg of oil equivalent energy use) in Greece in 1987 to that in 1989?
Make the answer very short. 1.01. What is the ratio of the Intensity (kg per kg of oil equivalent energy use) of Switzerland in 1987 to that in 1989?
Provide a succinct answer. 1.01. What is the ratio of the Intensity (kg per kg of oil equivalent energy use) in Greece in 1987 to that in 1990?
Offer a terse response. 1.02. What is the ratio of the Intensity (kg per kg of oil equivalent energy use) of Switzerland in 1987 to that in 1990?
Offer a terse response. 1.02. What is the ratio of the Intensity (kg per kg of oil equivalent energy use) of East Asia (all income levels) in 1987 to that in 1991?
Keep it short and to the point. 0.99. What is the ratio of the Intensity (kg per kg of oil equivalent energy use) of Greece in 1987 to that in 1991?
Make the answer very short. 1.03. What is the ratio of the Intensity (kg per kg of oil equivalent energy use) of Switzerland in 1987 to that in 1991?
Provide a succinct answer. 1.04. What is the ratio of the Intensity (kg per kg of oil equivalent energy use) of East Asia (all income levels) in 1987 to that in 1992?
Provide a succinct answer. 0.98. What is the ratio of the Intensity (kg per kg of oil equivalent energy use) in Greece in 1987 to that in 1992?
Your answer should be very brief. 1.04. What is the ratio of the Intensity (kg per kg of oil equivalent energy use) of Switzerland in 1987 to that in 1992?
Provide a short and direct response. 1.04. What is the ratio of the Intensity (kg per kg of oil equivalent energy use) in Greece in 1988 to that in 1989?
Provide a succinct answer. 1.01. What is the ratio of the Intensity (kg per kg of oil equivalent energy use) of Switzerland in 1988 to that in 1989?
Make the answer very short. 1.01. What is the ratio of the Intensity (kg per kg of oil equivalent energy use) of East Asia (all income levels) in 1988 to that in 1990?
Your response must be concise. 1.05. What is the ratio of the Intensity (kg per kg of oil equivalent energy use) in Greece in 1988 to that in 1990?
Your answer should be compact. 1.03. What is the ratio of the Intensity (kg per kg of oil equivalent energy use) of Switzerland in 1988 to that in 1990?
Offer a terse response. 1.03. What is the ratio of the Intensity (kg per kg of oil equivalent energy use) of East Asia (all income levels) in 1988 to that in 1991?
Keep it short and to the point. 1.01. What is the ratio of the Intensity (kg per kg of oil equivalent energy use) in Greece in 1988 to that in 1991?
Give a very brief answer. 1.04. What is the ratio of the Intensity (kg per kg of oil equivalent energy use) of Switzerland in 1988 to that in 1991?
Offer a terse response. 1.04. What is the ratio of the Intensity (kg per kg of oil equivalent energy use) of Greece in 1988 to that in 1992?
Make the answer very short. 1.04. What is the ratio of the Intensity (kg per kg of oil equivalent energy use) in Switzerland in 1988 to that in 1992?
Your response must be concise. 1.04. What is the ratio of the Intensity (kg per kg of oil equivalent energy use) in East Asia (all income levels) in 1989 to that in 1990?
Ensure brevity in your answer.  1.04. What is the ratio of the Intensity (kg per kg of oil equivalent energy use) of Greece in 1989 to that in 1990?
Your answer should be compact. 1.01. What is the ratio of the Intensity (kg per kg of oil equivalent energy use) of Switzerland in 1989 to that in 1990?
Offer a terse response. 1.02. What is the ratio of the Intensity (kg per kg of oil equivalent energy use) in Greece in 1989 to that in 1991?
Provide a succinct answer. 1.03. What is the ratio of the Intensity (kg per kg of oil equivalent energy use) of Switzerland in 1989 to that in 1991?
Ensure brevity in your answer.  1.03. What is the ratio of the Intensity (kg per kg of oil equivalent energy use) of East Asia (all income levels) in 1989 to that in 1992?
Provide a succinct answer. 0.99. What is the ratio of the Intensity (kg per kg of oil equivalent energy use) of Greece in 1989 to that in 1992?
Keep it short and to the point. 1.03. What is the ratio of the Intensity (kg per kg of oil equivalent energy use) of Switzerland in 1989 to that in 1992?
Give a very brief answer. 1.03. What is the ratio of the Intensity (kg per kg of oil equivalent energy use) of Greece in 1990 to that in 1991?
Provide a succinct answer. 1.01. What is the ratio of the Intensity (kg per kg of oil equivalent energy use) in Switzerland in 1990 to that in 1991?
Offer a very short reply. 1.01. What is the ratio of the Intensity (kg per kg of oil equivalent energy use) of East Asia (all income levels) in 1990 to that in 1992?
Offer a terse response. 0.95. What is the ratio of the Intensity (kg per kg of oil equivalent energy use) in Greece in 1990 to that in 1992?
Your answer should be compact. 1.02. What is the ratio of the Intensity (kg per kg of oil equivalent energy use) of Switzerland in 1990 to that in 1992?
Make the answer very short. 1.02. What is the ratio of the Intensity (kg per kg of oil equivalent energy use) of Greece in 1991 to that in 1992?
Offer a terse response. 1.01. What is the difference between the highest and the second highest Intensity (kg per kg of oil equivalent energy use) of East Asia (all income levels)?
Keep it short and to the point. 0.01. What is the difference between the highest and the second highest Intensity (kg per kg of oil equivalent energy use) in Greece?
Make the answer very short. 0.02. What is the difference between the highest and the second highest Intensity (kg per kg of oil equivalent energy use) in Switzerland?
Keep it short and to the point. 0.03. What is the difference between the highest and the lowest Intensity (kg per kg of oil equivalent energy use) in East Asia (all income levels)?
Your answer should be very brief. 0.13. What is the difference between the highest and the lowest Intensity (kg per kg of oil equivalent energy use) of Greece?
Keep it short and to the point. 0.15. What is the difference between the highest and the lowest Intensity (kg per kg of oil equivalent energy use) of Switzerland?
Your response must be concise. 0.11. 